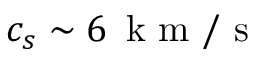<formula> <loc_0><loc_0><loc_500><loc_500>c _ { s } \sim 6 \, { k m } / { s }</formula> 